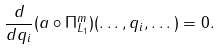<formula> <loc_0><loc_0><loc_500><loc_500>\frac { d } { d q _ { i } } ( a \circ \Pi _ { L _ { 1 } } ^ { m } ) ( \dots , q _ { i } , \dots ) = 0 .</formula> 